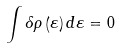<formula> <loc_0><loc_0><loc_500><loc_500>\int \delta \rho \left ( \varepsilon \right ) d \varepsilon = 0</formula> 